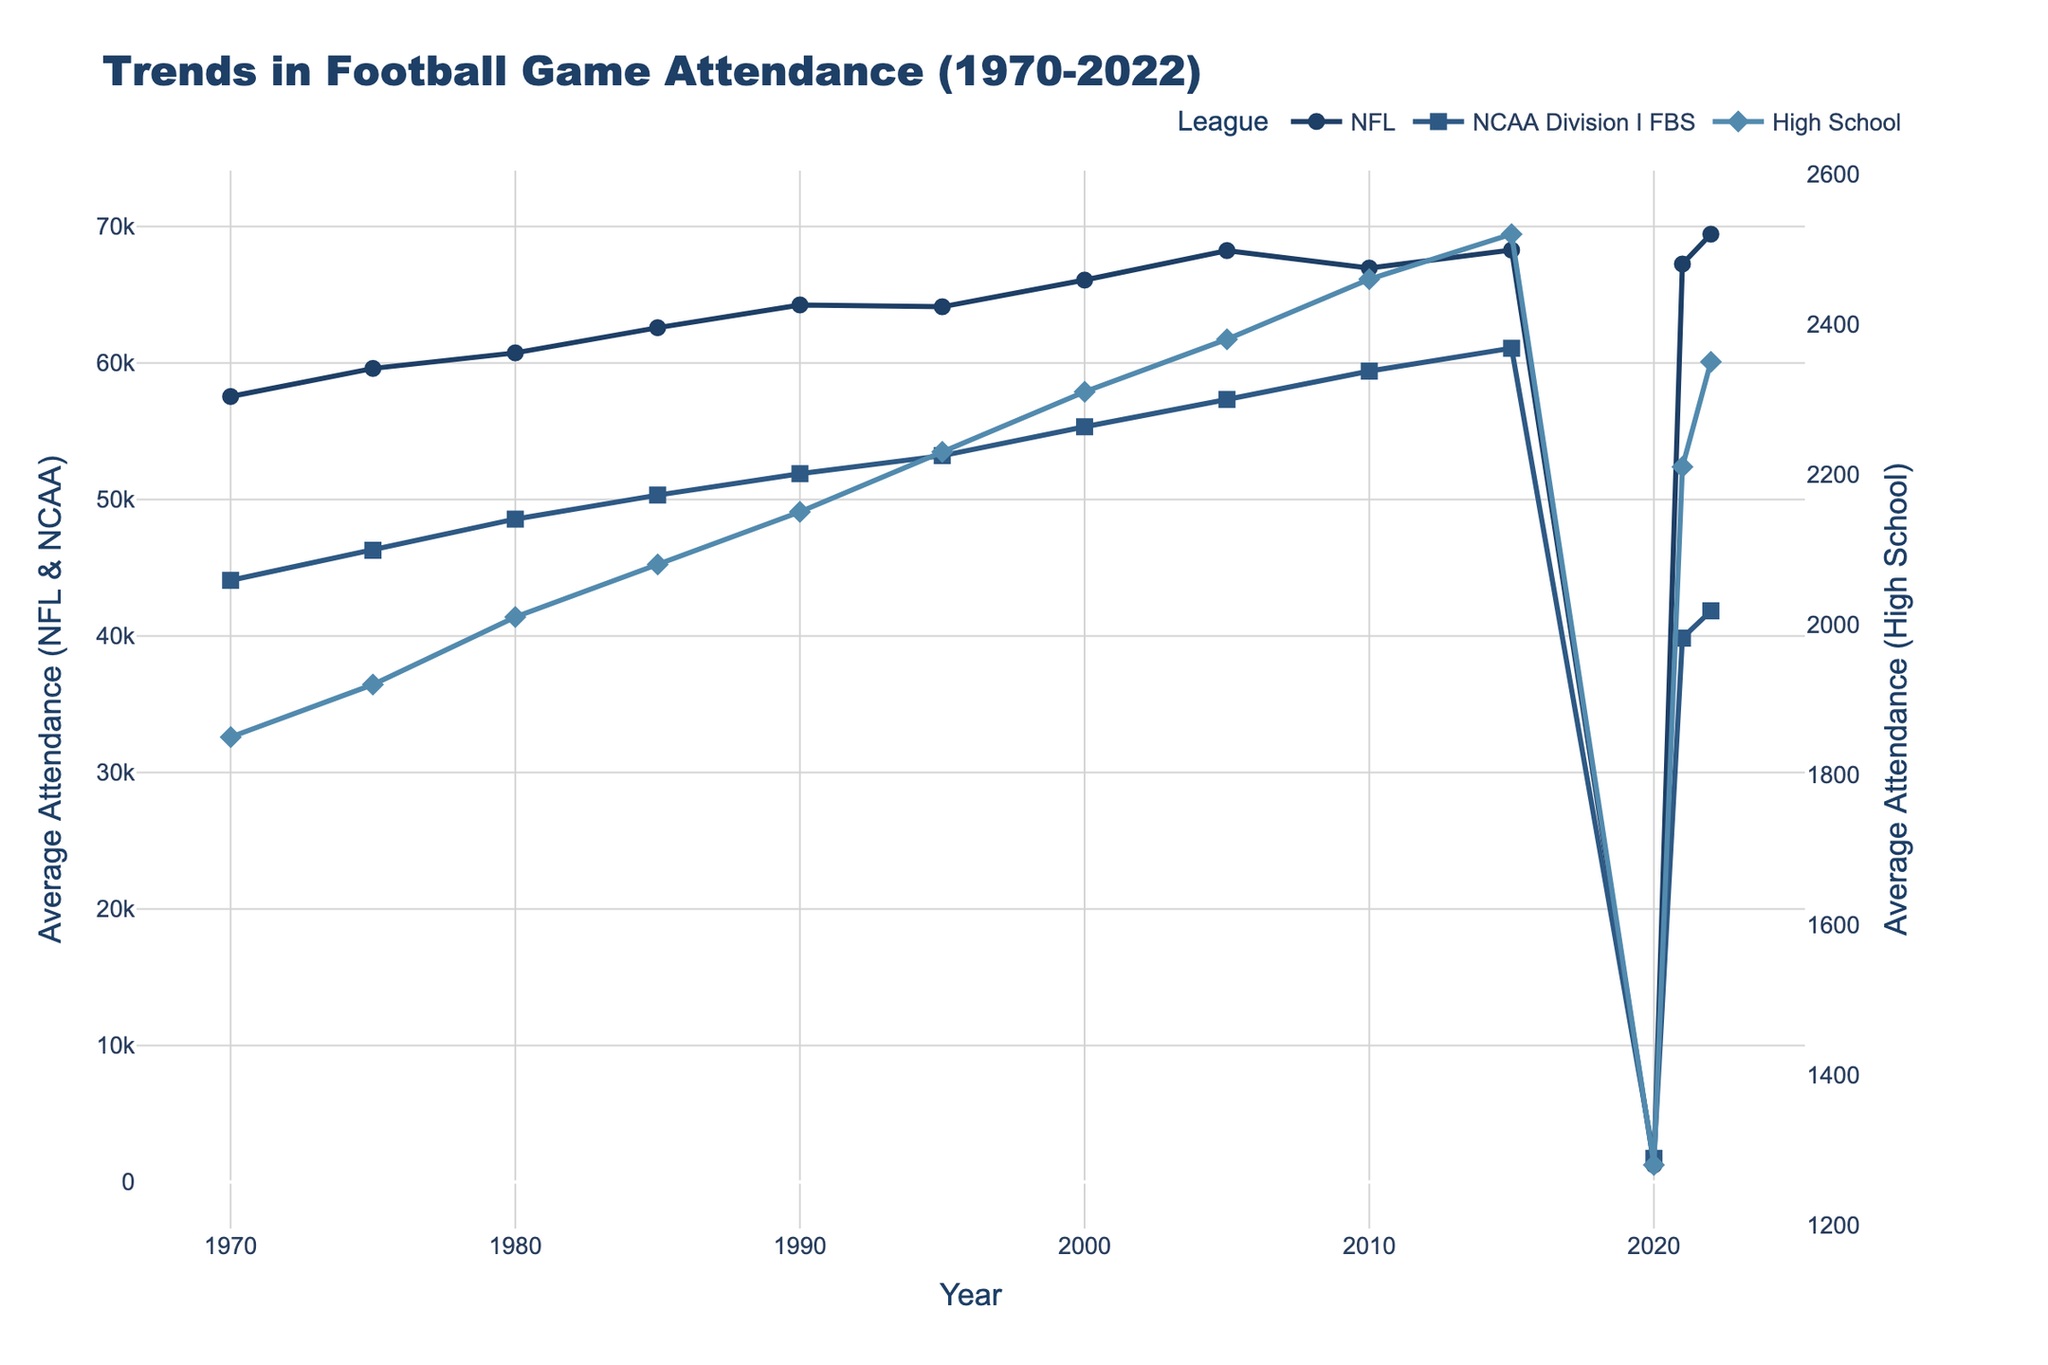What is the trend in NFL attendance from 1970 to 2022? The NFL attendance has shown a generally upward trend from around 57,546 in 1970 to 69,442 in 2022, with significant peaks and a notable drop in 2020.
Answer: Upward trend How does the attendance drop in 2020 compare across NFL, NCAA, and High School leagues? In 2020, all three leagues experienced significant drops, with NFL attendance dropping to 1,243, NCAA to 1,731, and High School to 1,280.
Answer: Significant drops Which year had the highest attendance for NCAA Division I FBS? Looking at the NCAA Division I FBS data, the highest attendance was in 2015, with a value of 61,087.
Answer: 2015 How did high school football attendance change from 1970 to 2022? The high school football attendance increased from 1,850 in 1970 to 2,350 in 2022. Despite fluctuations, the overall trend is upward.
Answer: Upward trend In which years did the NFL attendance experience a decline? NFL attendance declined in 2010, 2020 (significantly), and after 2020, it rebounded but did not reach the previous peak.
Answer: 2010, 2020 Compare the 2021 NFL attendance to the NCAA Division I FBS attendance in the same year. In 2021, the NFL attendance was 67,254, significantly higher than the NCAA Division I FBS attendance of 39,848.
Answer: NFL higher What is the average NFL attendance over the 52-year period (1970-2022)? Sum the NFL attendance values from 1970 to 2022 (57546, 59605, 60745, 62590, 64258, 64124, 66078, 68241, 66960, 68278, 1243, 67254, 69442) which equals 611,364. Divide by the number of years (52).
Answer: 611,364 / 52 ≈ 11,757 How do the trends in NCAA and High School attendance compare? Both NCAA and High School attendance show upward trends, with NCAA starting higher and increasing more significantly than High School.
Answer: Both upward What is the difference between the highest and lowest NFL attendance values? The highest NFL attendance was 69,442 in 2022 and the lowest was 1,243 in 2020. The difference is 69,442 - 1,243 = 68,199.
Answer: 68,199 What happened to high school football attendance in 2020, and how does it compare to 2021 values? High school football attendance decreased to 1,280 in 2020 and then increased to 2,210 in 2021.
Answer: Decreased then increased 